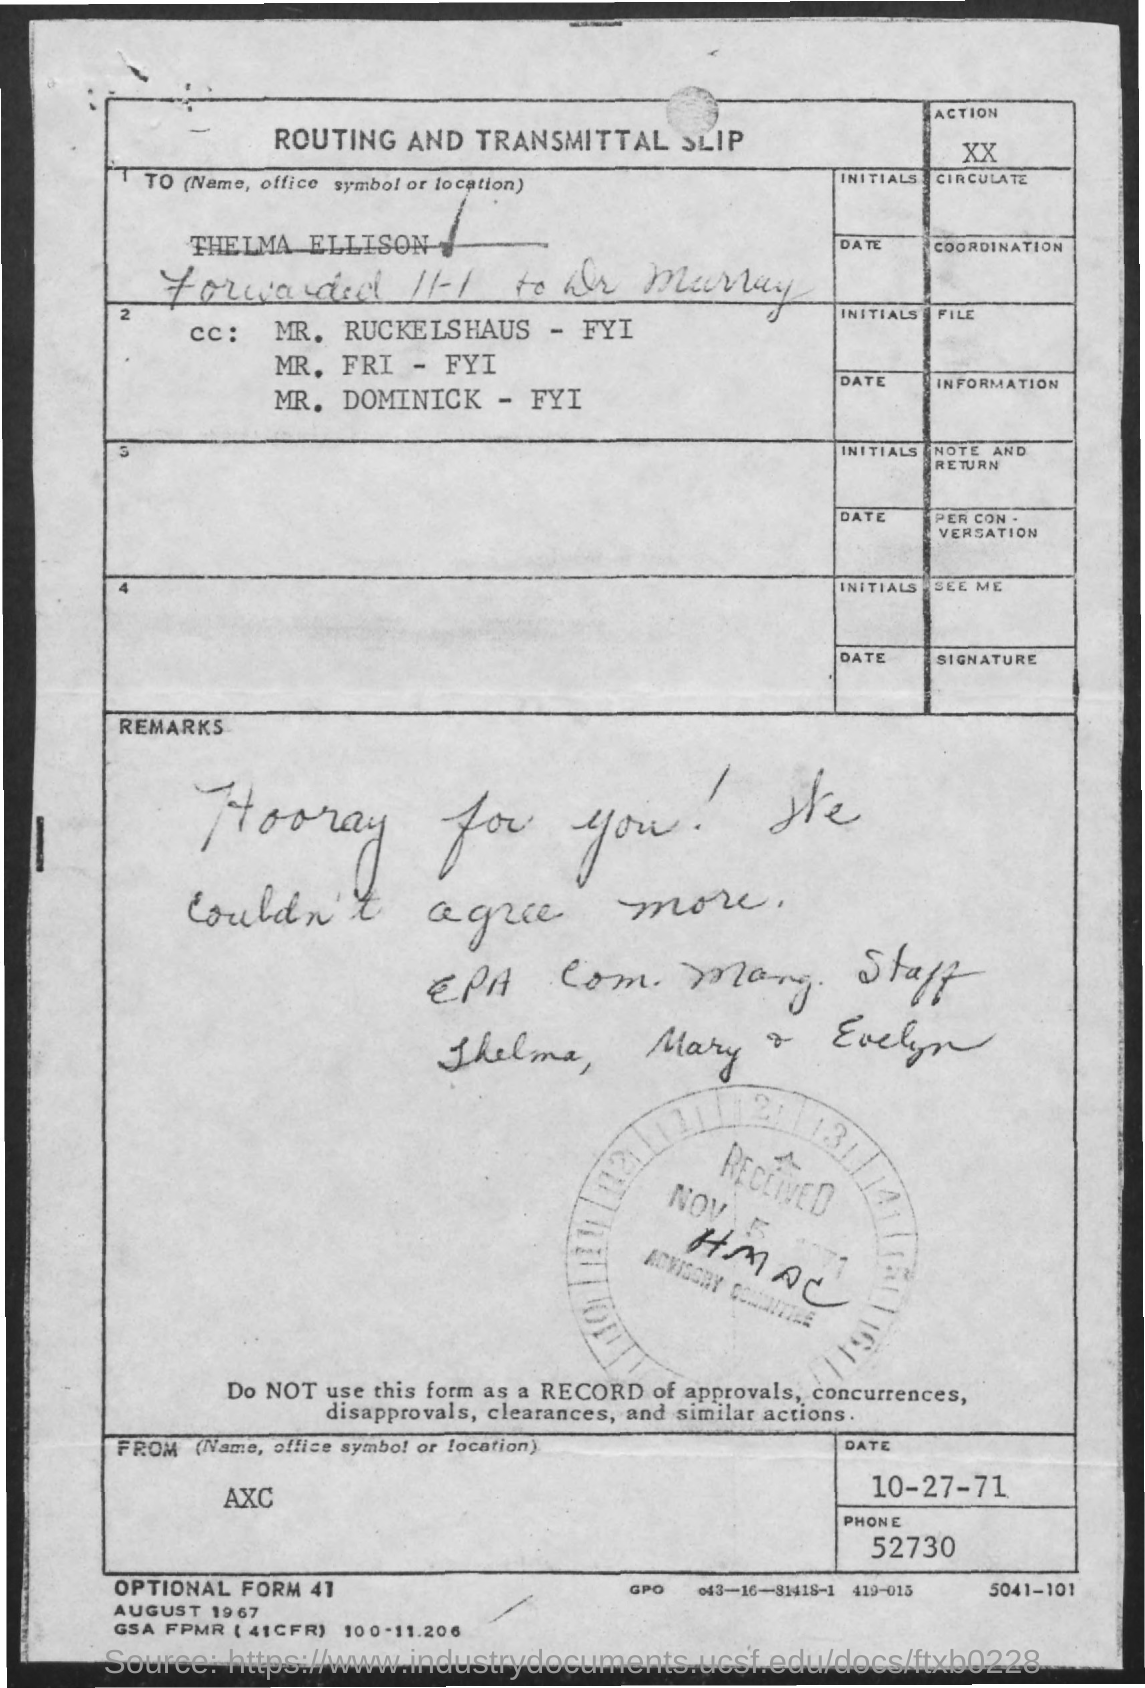Point out several critical features in this image. The received date mentioned is November 5, 1971. The phone number mentioned is 52730... The date mentioned is October 27, 1971. 